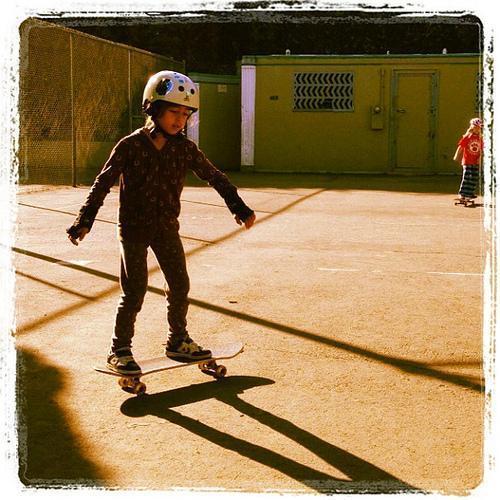How many children are there?
Give a very brief answer. 2. 